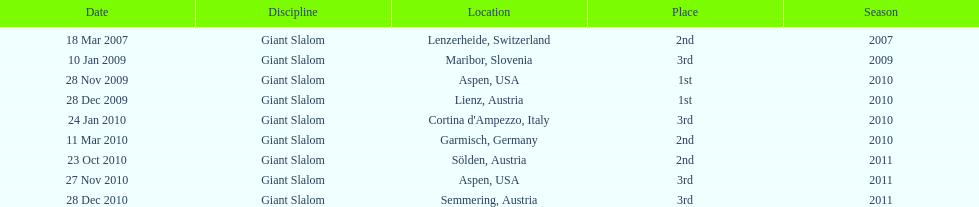How many races were in 2010? 5. 